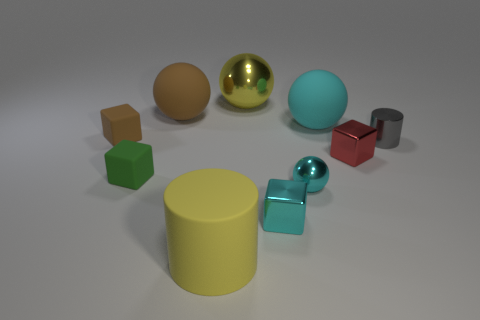What is the material of the green block?
Offer a very short reply. Rubber. How many cubes are either big brown matte objects or brown objects?
Your response must be concise. 1. Is the material of the yellow cylinder the same as the small gray cylinder?
Make the answer very short. No. What is the size of the red thing that is the same shape as the green object?
Offer a terse response. Small. There is a cube that is both left of the big brown matte thing and behind the green matte cube; what material is it?
Offer a terse response. Rubber. Are there an equal number of big cyan matte objects that are on the right side of the small gray shiny cylinder and small gray rubber spheres?
Keep it short and to the point. Yes. What number of things are cylinders that are to the right of the red metallic cube or large rubber objects?
Keep it short and to the point. 4. There is a big matte ball that is on the right side of the brown ball; is its color the same as the small ball?
Offer a terse response. Yes. There is a rubber thing on the right side of the big cylinder; what is its size?
Give a very brief answer. Large. There is a big rubber object in front of the cyan sphere in front of the small cylinder; what shape is it?
Your response must be concise. Cylinder. 